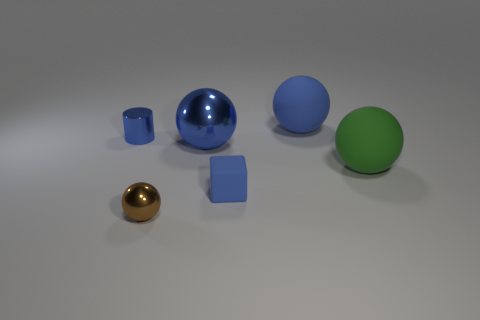Is the blue sphere that is in front of the tiny blue cylinder made of the same material as the sphere that is in front of the blue cube?
Your answer should be very brief. Yes. There is a green sphere behind the brown metal thing; is there a blue matte object that is behind it?
Your response must be concise. Yes. What is the color of the small thing that is the same material as the cylinder?
Your response must be concise. Brown. What number of small rubber cubes have the same color as the cylinder?
Make the answer very short. 1. What is the size of the blue thing that is to the left of the tiny blue matte thing and behind the large metallic ball?
Offer a terse response. Small. Is the material of the green sphere the same as the tiny cylinder?
Make the answer very short. No. What number of things are either rubber blocks or small blue metal things?
Keep it short and to the point. 2. What number of large blue objects are made of the same material as the small cylinder?
Keep it short and to the point. 1. What is the size of the blue rubber thing that is the same shape as the brown shiny thing?
Keep it short and to the point. Large. There is a tiny shiny cylinder; are there any blue cylinders in front of it?
Keep it short and to the point. No. 